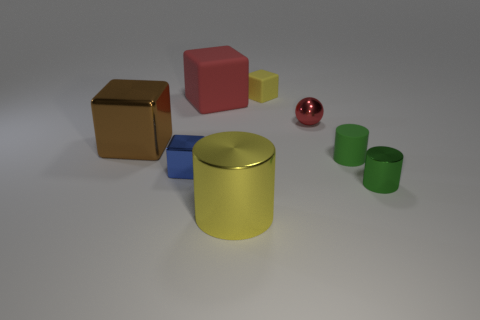There is a small rubber object that is the same shape as the big matte thing; what is its color?
Provide a short and direct response. Yellow. Is there any other thing that has the same shape as the yellow matte object?
Offer a very short reply. Yes. Does the brown metallic thing have the same shape as the large metal thing in front of the brown metallic cube?
Provide a short and direct response. No. What is the material of the big red object?
Your answer should be compact. Rubber. The red matte thing that is the same shape as the brown object is what size?
Offer a very short reply. Large. What number of other things are there of the same material as the red cube
Your response must be concise. 2. Does the big brown cube have the same material as the yellow block behind the big cylinder?
Offer a very short reply. No. Are there fewer small green shiny things that are left of the big rubber cube than large cylinders that are right of the yellow shiny cylinder?
Offer a very short reply. No. What is the color of the thing that is right of the green matte thing?
Ensure brevity in your answer.  Green. What number of other things are there of the same color as the large metal cube?
Your response must be concise. 0. 